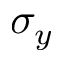<formula> <loc_0><loc_0><loc_500><loc_500>\sigma _ { y }</formula> 